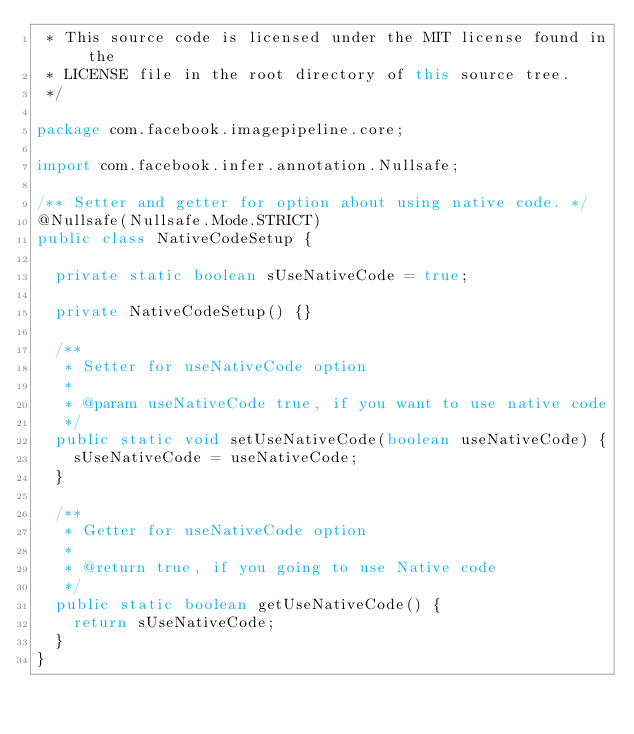<code> <loc_0><loc_0><loc_500><loc_500><_Java_> * This source code is licensed under the MIT license found in the
 * LICENSE file in the root directory of this source tree.
 */

package com.facebook.imagepipeline.core;

import com.facebook.infer.annotation.Nullsafe;

/** Setter and getter for option about using native code. */
@Nullsafe(Nullsafe.Mode.STRICT)
public class NativeCodeSetup {

  private static boolean sUseNativeCode = true;

  private NativeCodeSetup() {}

  /**
   * Setter for useNativeCode option
   *
   * @param useNativeCode true, if you want to use native code
   */
  public static void setUseNativeCode(boolean useNativeCode) {
    sUseNativeCode = useNativeCode;
  }

  /**
   * Getter for useNativeCode option
   *
   * @return true, if you going to use Native code
   */
  public static boolean getUseNativeCode() {
    return sUseNativeCode;
  }
}
</code> 